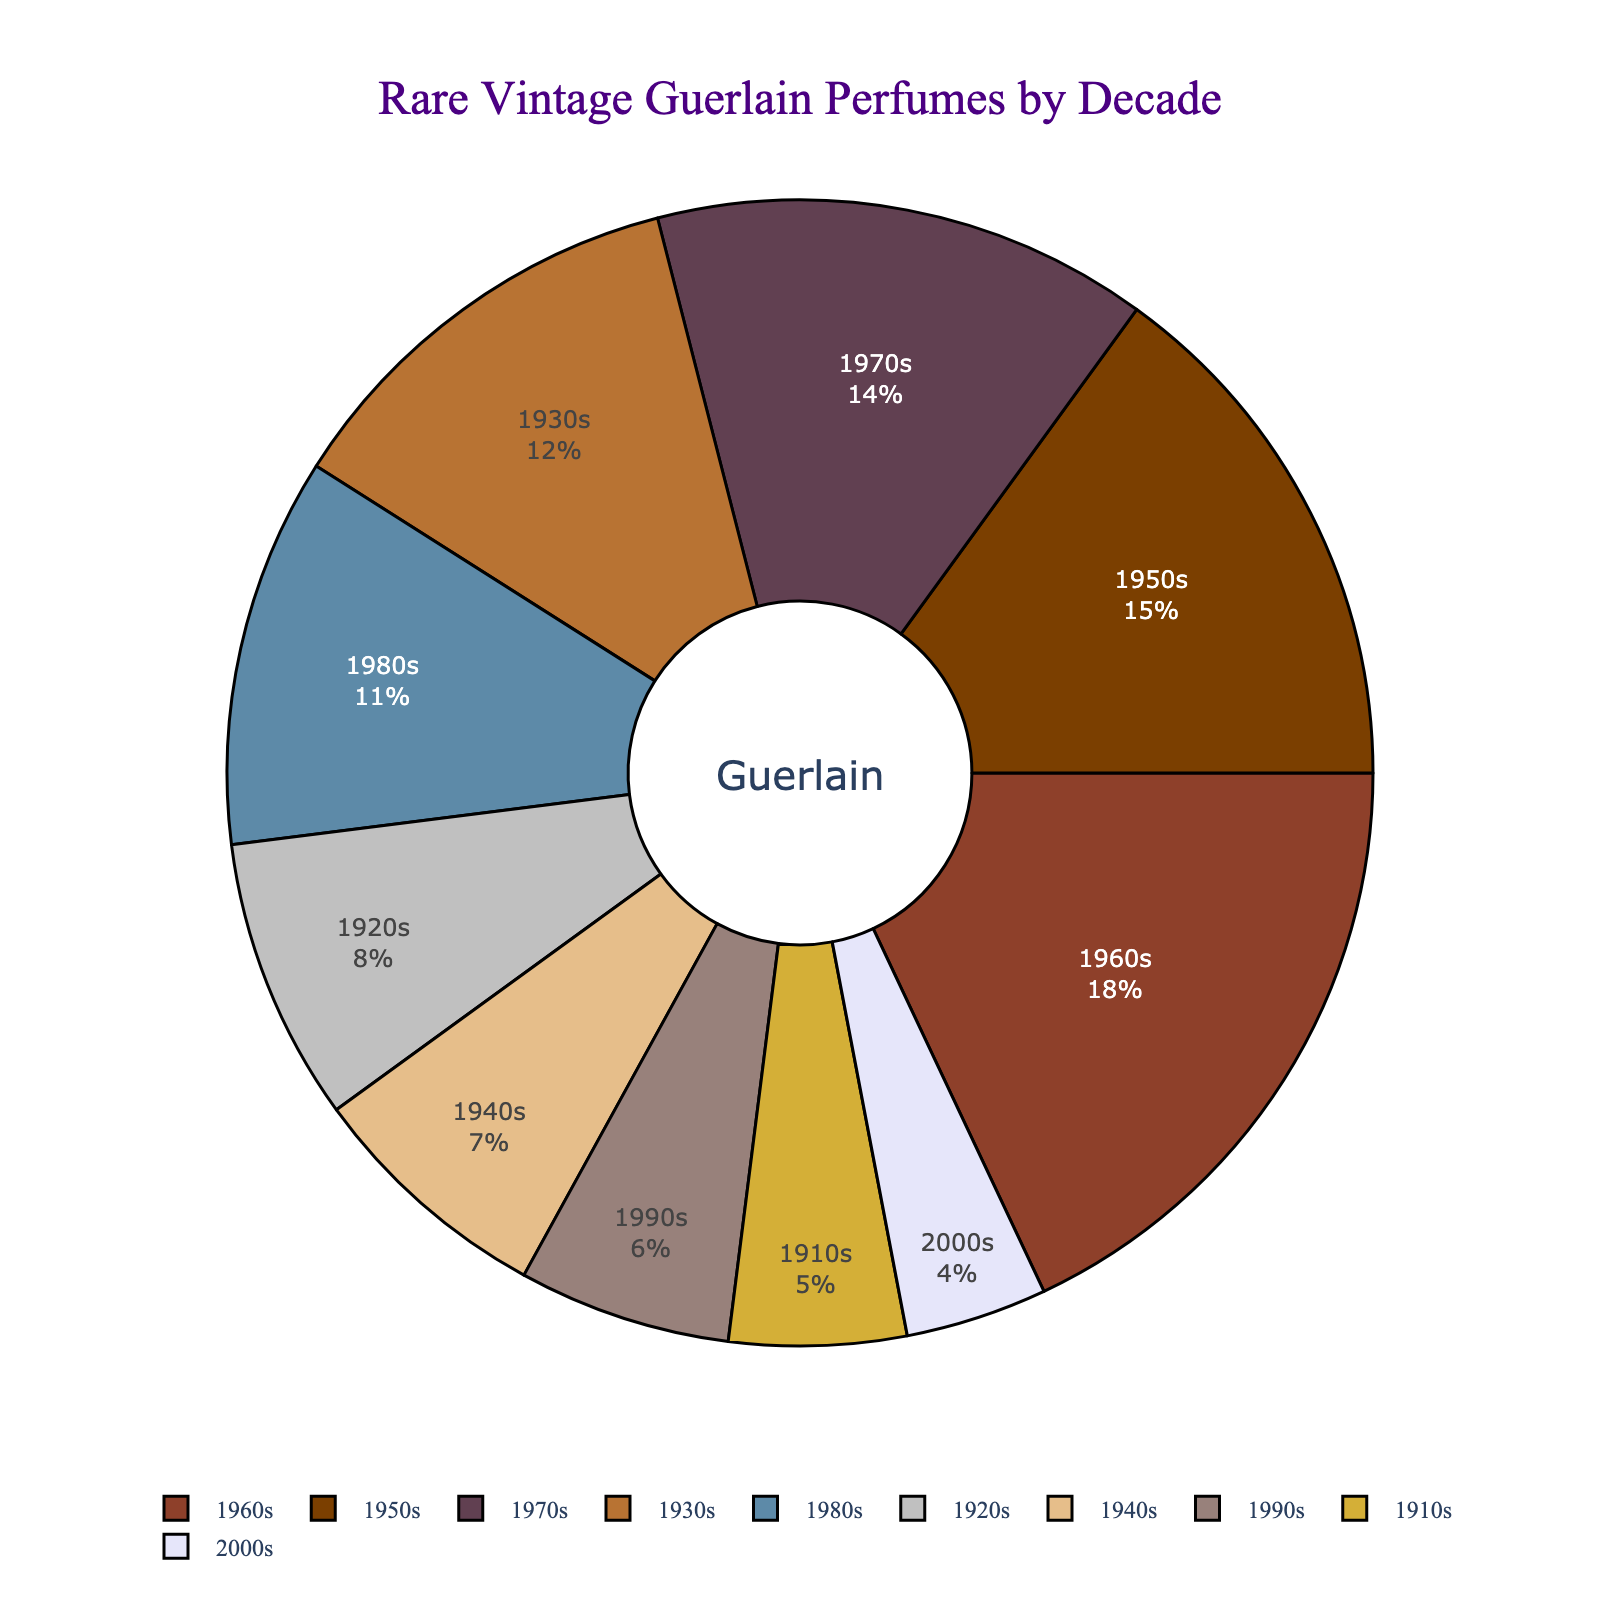Which decade has the highest percentage of rare vintage Guerlain perfumes? To determine the decade with the highest percentage, observe the data for the largest segment in the pie chart. The decade with the largest slice, representing 18%, is the 1960s.
Answer: 1960s What is the total percentage of rare vintage Guerlain perfumes released in the decades of the 1930s and 1950s combined? Sum the percentages of rare vintage perfumes from the 1930s and the 1950s. From the chart, the 1930s account for 12% and the 1950s for 15%. Adding these gives 12% + 15% = 27%.
Answer: 27% How does the percentage of rare vintage Guerlain perfumes released in the 1970s compare to those released in the 1980s? Compare the segments for the 1970s and 1980s. The percentage for the 1970s is 14%, while that for the 1980s is 11%. The 1970s has a higher percentage than the 1980s.
Answer: 1970s > 1980s What is the percentage difference between the rare vintage Guerlain perfumes of the 1960s and the 2000s? Subtract the percentage of the 2000s from that of the 1960s. The 1960s have 18% and the 2000s have 4%. The difference is 18% - 4% = 14%.
Answer: 14% Which decades have an equal percentage of rare vintage Guerlain perfumes? Compare the percentages for all decades. The 1910s have 5% and the 1990s have 6%, each are unique. None of the decades have the same percentage.
Answer: None What is the average percentage of rare vintage Guerlain perfumes released across all decades? Calculate the average by summing all percentages and dividing by the number of decades. The total sum is 5% + 8% + 12% + 7% + 15% + 18% + 14% + 11% + 6% + 4% = 100%. Dividing by 10 decades gives 100% / 10 = 10%.
Answer: 10% Which decade has the smallest percentage of rare vintage Guerlain perfumes? Identify the smallest segment in the pie chart, which represents the least percentage. The decade with the smallest segment at 4% is the 2000s.
Answer: 2000s 